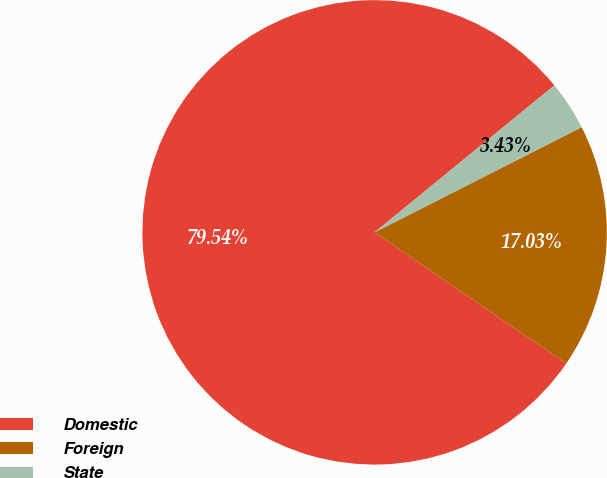<chart> <loc_0><loc_0><loc_500><loc_500><pie_chart><fcel>Domestic<fcel>Foreign<fcel>State<nl><fcel>79.54%<fcel>17.03%<fcel>3.43%<nl></chart> 